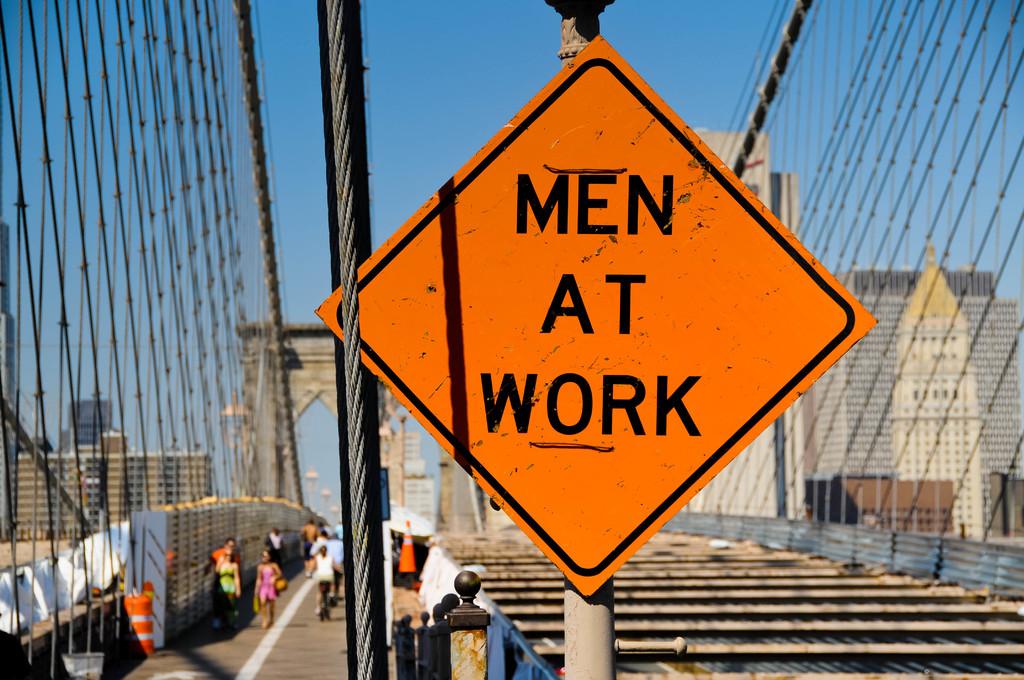Who is at work?
Keep it short and to the point. Men. What are the men doing?
Make the answer very short. Working. 